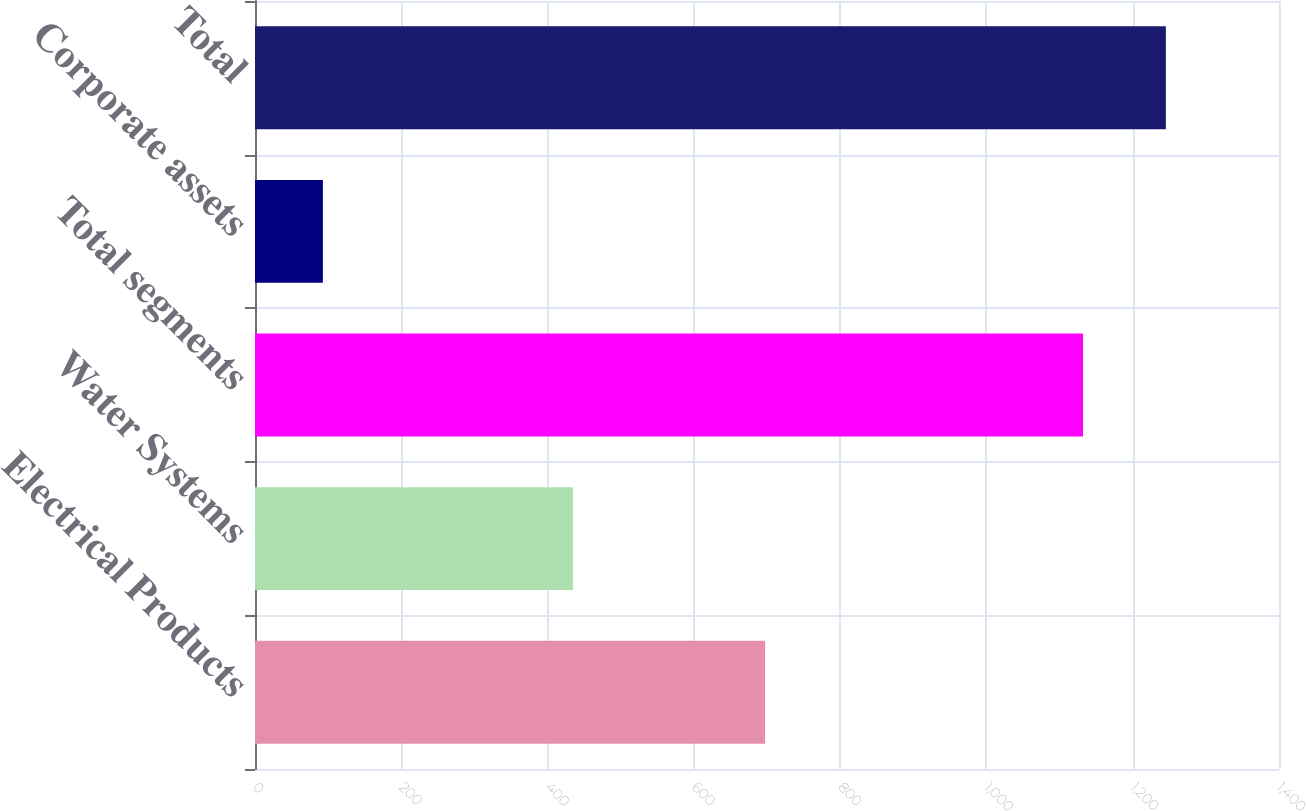Convert chart. <chart><loc_0><loc_0><loc_500><loc_500><bar_chart><fcel>Electrical Products<fcel>Water Systems<fcel>Total segments<fcel>Corporate assets<fcel>Total<nl><fcel>697.4<fcel>434.7<fcel>1132.1<fcel>92.8<fcel>1245.31<nl></chart> 